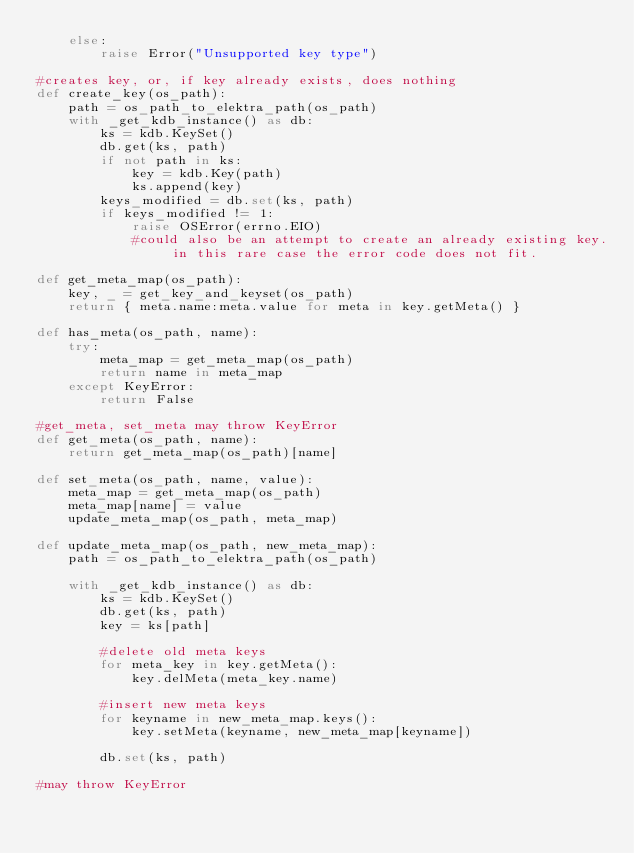<code> <loc_0><loc_0><loc_500><loc_500><_Python_>    else:
        raise Error("Unsupported key type")

#creates key, or, if key already exists, does nothing
def create_key(os_path):
    path = os_path_to_elektra_path(os_path)
    with _get_kdb_instance() as db:
        ks = kdb.KeySet()
        db.get(ks, path)
        if not path in ks:
            key = kdb.Key(path)
            ks.append(key)
        keys_modified = db.set(ks, path)
        if keys_modified != 1:
            raise OSError(errno.EIO)
            #could also be an attempt to create an already existing key. in this rare case the error code does not fit.

def get_meta_map(os_path):
    key, _ = get_key_and_keyset(os_path)
    return { meta.name:meta.value for meta in key.getMeta() }

def has_meta(os_path, name):
    try:
        meta_map = get_meta_map(os_path)
        return name in meta_map
    except KeyError:
        return False
    
#get_meta, set_meta may throw KeyError
def get_meta(os_path, name):
    return get_meta_map(os_path)[name]

def set_meta(os_path, name, value):
    meta_map = get_meta_map(os_path)
    meta_map[name] = value
    update_meta_map(os_path, meta_map)

def update_meta_map(os_path, new_meta_map):
    path = os_path_to_elektra_path(os_path)

    with _get_kdb_instance() as db:
        ks = kdb.KeySet()
        db.get(ks, path)
        key = ks[path]

        #delete old meta keys
        for meta_key in key.getMeta():
            key.delMeta(meta_key.name)
        
        #insert new meta keys
        for keyname in new_meta_map.keys():
            key.setMeta(keyname, new_meta_map[keyname])

        db.set(ks, path)

#may throw KeyError</code> 